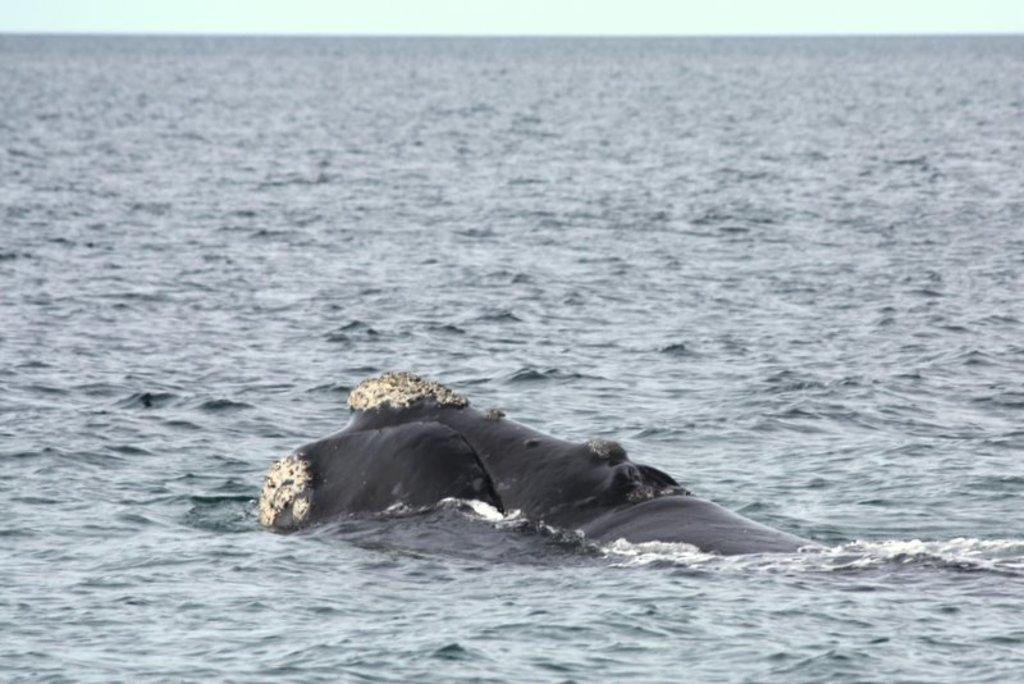What type of animal can be seen in the image? There is a sea animal in the image. What is the primary element surrounding the sea animal? There is water in the image. What can be seen in the background of the image? The sky is visible in the background of the image. What type of curtain can be seen hanging from the sea animal in the image? There is no curtain present in the image; it features a sea animal in water with the sky visible in the background. 